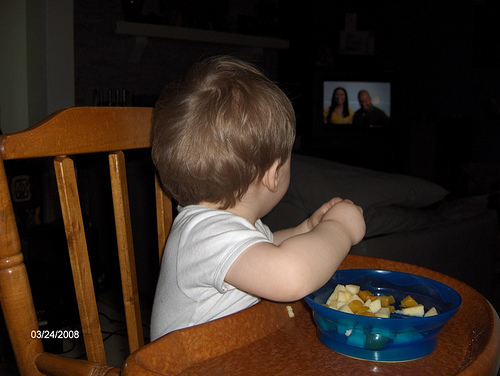<image>
Can you confirm if the baby is in front of the chair? Yes. The baby is positioned in front of the chair, appearing closer to the camera viewpoint. 